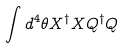Convert formula to latex. <formula><loc_0><loc_0><loc_500><loc_500>\int d ^ { 4 } \theta X ^ { \dagger } X Q ^ { \dagger } Q</formula> 